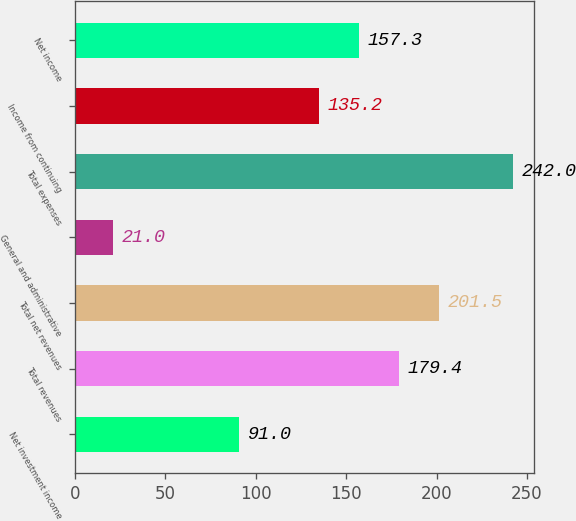Convert chart to OTSL. <chart><loc_0><loc_0><loc_500><loc_500><bar_chart><fcel>Net investment income<fcel>Total revenues<fcel>Total net revenues<fcel>General and administrative<fcel>Total expenses<fcel>Income from continuing<fcel>Net income<nl><fcel>91<fcel>179.4<fcel>201.5<fcel>21<fcel>242<fcel>135.2<fcel>157.3<nl></chart> 